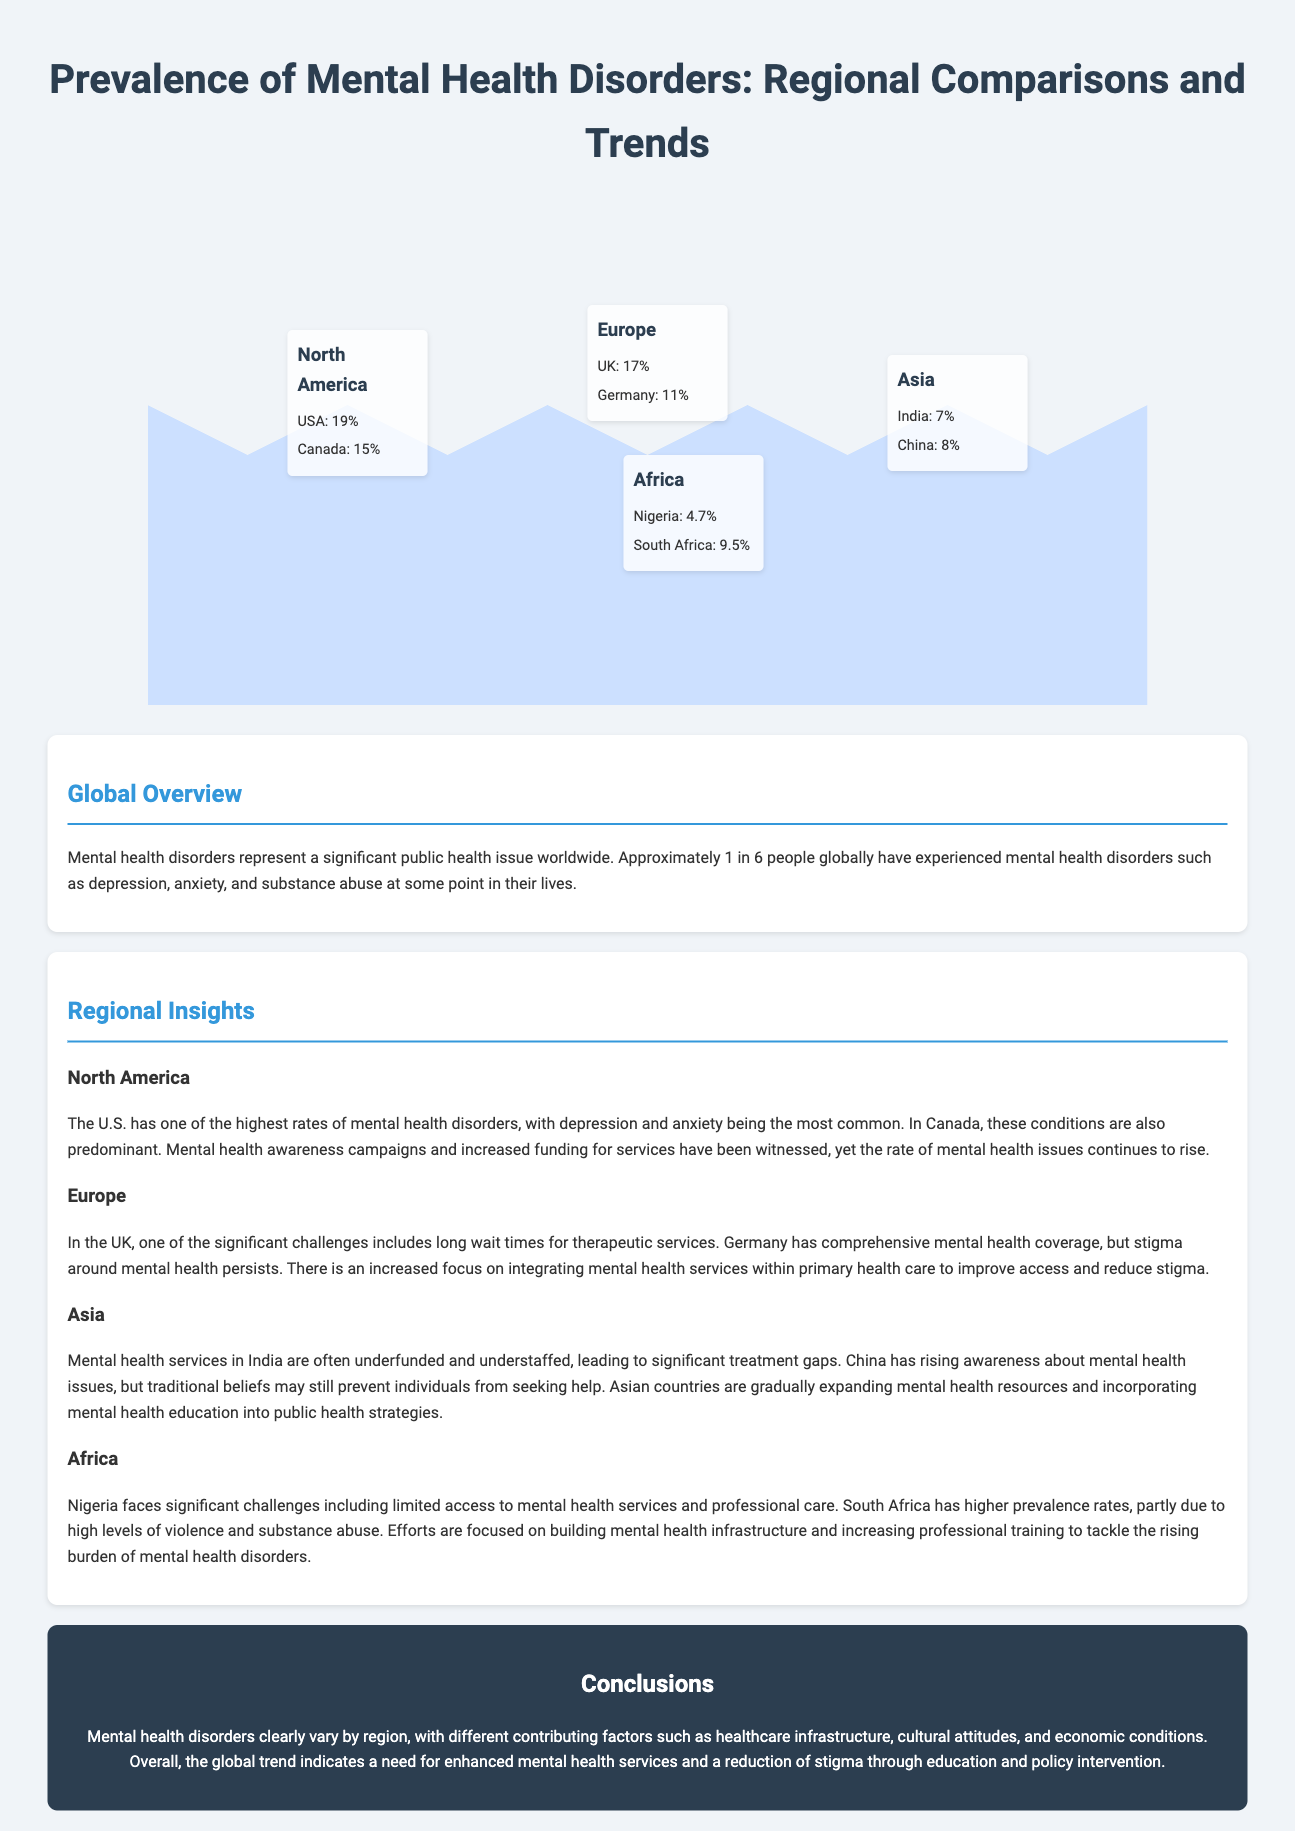What is the prevalence of mental health disorders in the USA? The prevalence of mental health disorders in the USA is indicated as 19% in the document.
Answer: 19% What are the two most common mental health disorders in North America? The document states that depression and anxiety are the most common mental health disorders in North America.
Answer: Depression and anxiety What is the prevalence rate of mental health disorders in Nigeria? The document specifies that Nigeria has a prevalence rate of 4.7% for mental health disorders.
Answer: 4.7% Which region has the highest reported prevalence rate of mental health disorders? The information indicates that North America has the highest reported prevalence rate with the USA at 19% and Canada at 15%.
Answer: North America What are the mental health issues primarily recognized in Asia? The document emphasizes treatment gaps due to underfunded mental health services and the impact of traditional beliefs inhibiting help-seeking in Asia.
Answer: Treatment gaps How does the UK address mental health service accessibility? The document mentions that one significant challenge faced in the UK includes long wait times for therapeutic services.
Answer: Long wait times What initiatives are African nations focusing on in relation to mental health? The document notes that efforts are being made to build mental health infrastructure and increase professional training.
Answer: Building mental health infrastructure What conclusion is drawn regarding global trends in mental health services? The document concludes that there is a clear indication of a need for enhanced mental health services and stigma reduction through education and policy intervention.
Answer: Enhanced mental health services How are mental health services in India described in the document? The document describes mental health services in India as often underfunded and understaffed, leading to significant treatment gaps.
Answer: Underfunded and understaffed 